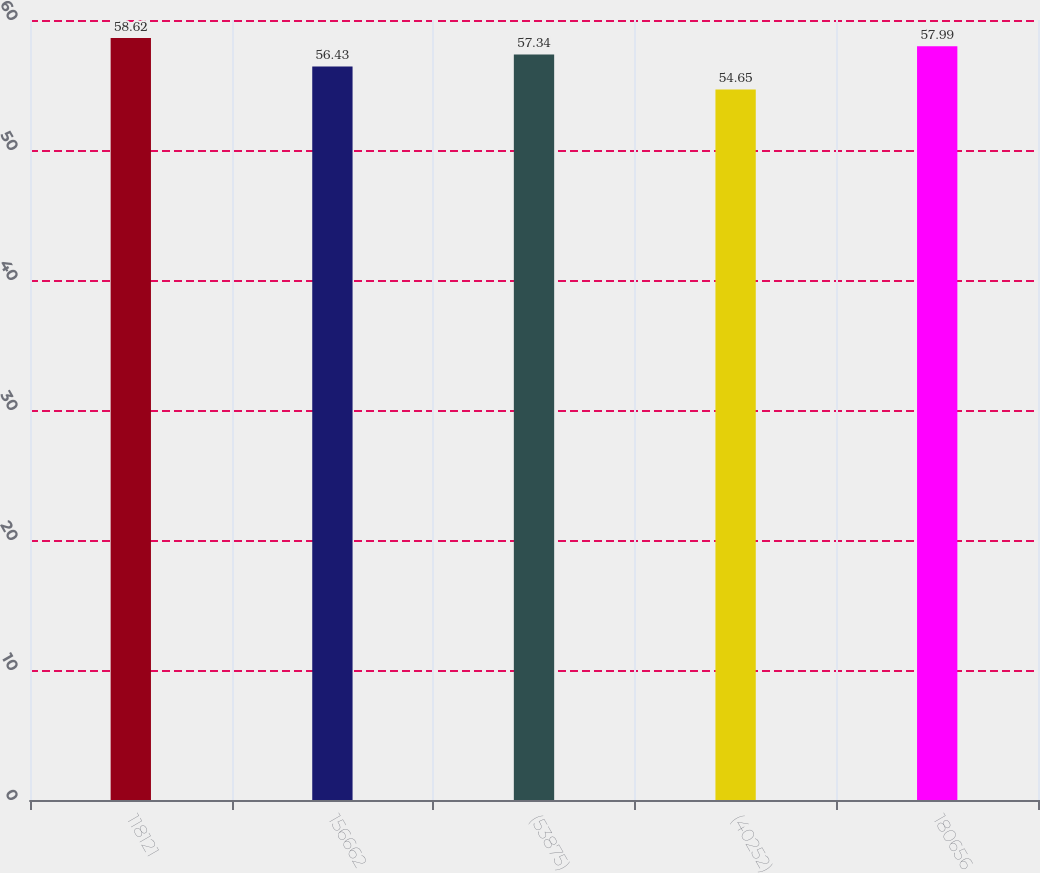Convert chart to OTSL. <chart><loc_0><loc_0><loc_500><loc_500><bar_chart><fcel>118121<fcel>156662<fcel>(53875)<fcel>(40252)<fcel>180656<nl><fcel>58.62<fcel>56.43<fcel>57.34<fcel>54.65<fcel>57.99<nl></chart> 